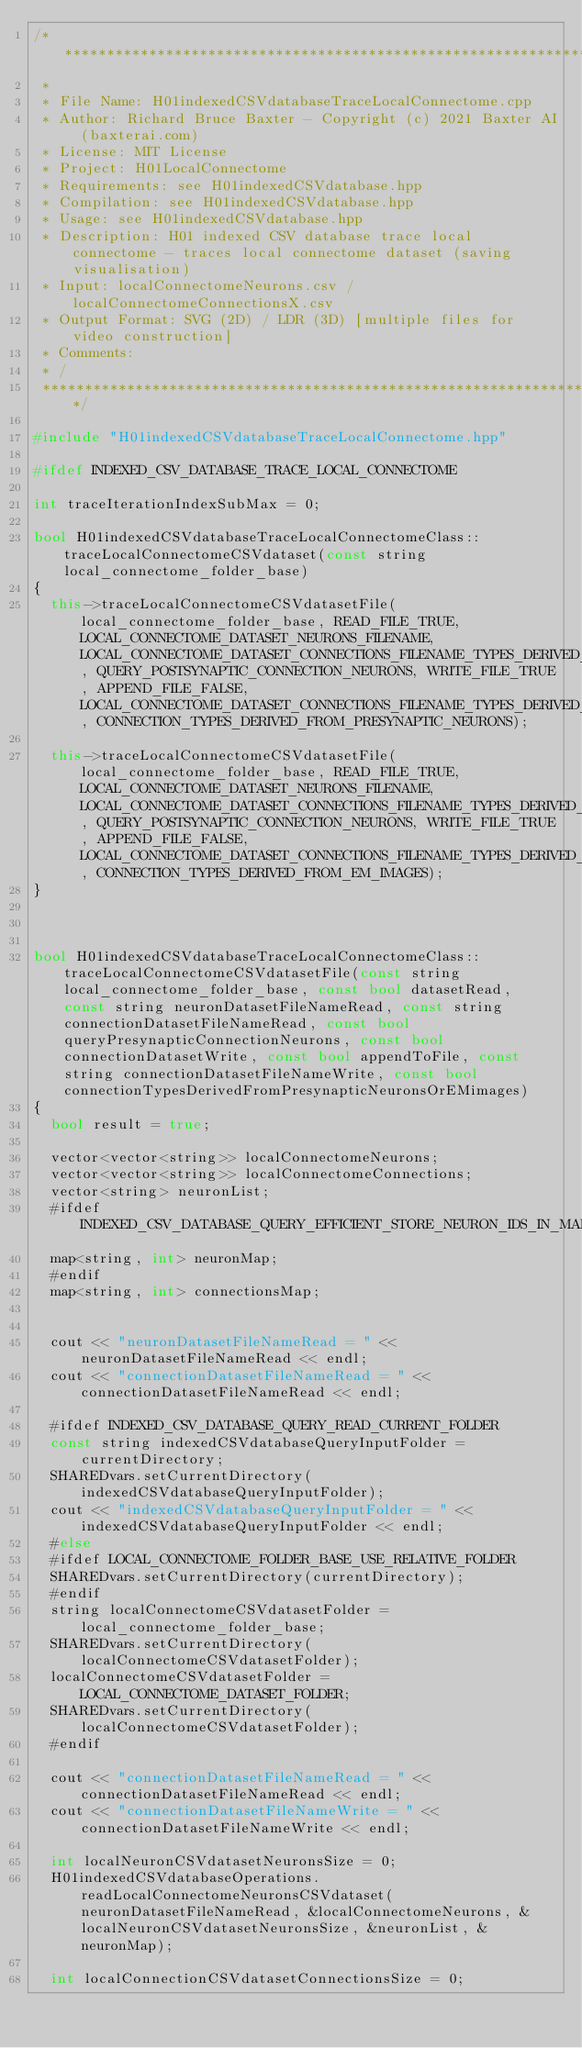<code> <loc_0><loc_0><loc_500><loc_500><_C++_>/*******************************************************************************
 *
 * File Name: H01indexedCSVdatabaseTraceLocalConnectome.cpp
 * Author: Richard Bruce Baxter - Copyright (c) 2021 Baxter AI (baxterai.com)
 * License: MIT License
 * Project: H01LocalConnectome
 * Requirements: see H01indexedCSVdatabase.hpp
 * Compilation: see H01indexedCSVdatabase.hpp
 * Usage: see H01indexedCSVdatabase.hpp
 * Description: H01 indexed CSV database trace local connectome - traces local connectome dataset (saving visualisation)
 * Input: localConnectomeNeurons.csv / localConnectomeConnectionsX.csv
 * Output Format: SVG (2D) / LDR (3D) [multiple files for video construction]
 * Comments:
 * /
 *******************************************************************************/

#include "H01indexedCSVdatabaseTraceLocalConnectome.hpp"

#ifdef INDEXED_CSV_DATABASE_TRACE_LOCAL_CONNECTOME

int traceIterationIndexSubMax = 0;

bool H01indexedCSVdatabaseTraceLocalConnectomeClass::traceLocalConnectomeCSVdataset(const string local_connectome_folder_base)
{
	this->traceLocalConnectomeCSVdatasetFile(local_connectome_folder_base, READ_FILE_TRUE, LOCAL_CONNECTOME_DATASET_NEURONS_FILENAME, LOCAL_CONNECTOME_DATASET_CONNECTIONS_FILENAME_TYPES_DERIVED_FROM_PRESYNAPTIC_NEURONS, QUERY_POSTSYNAPTIC_CONNECTION_NEURONS, WRITE_FILE_TRUE, APPEND_FILE_FALSE, LOCAL_CONNECTOME_DATASET_CONNECTIONS_FILENAME_TYPES_DERIVED_FROM_PRESYNAPTIC_NEURONS, CONNECTION_TYPES_DERIVED_FROM_PRESYNAPTIC_NEURONS);

	this->traceLocalConnectomeCSVdatasetFile(local_connectome_folder_base, READ_FILE_TRUE, LOCAL_CONNECTOME_DATASET_NEURONS_FILENAME, LOCAL_CONNECTOME_DATASET_CONNECTIONS_FILENAME_TYPES_DERIVED_FROM_EM_IMAGES, QUERY_POSTSYNAPTIC_CONNECTION_NEURONS, WRITE_FILE_TRUE, APPEND_FILE_FALSE, LOCAL_CONNECTOME_DATASET_CONNECTIONS_FILENAME_TYPES_DERIVED_FROM_EM_IMAGES, CONNECTION_TYPES_DERIVED_FROM_EM_IMAGES);
}



bool H01indexedCSVdatabaseTraceLocalConnectomeClass::traceLocalConnectomeCSVdatasetFile(const string local_connectome_folder_base, const bool datasetRead, const string neuronDatasetFileNameRead, const string connectionDatasetFileNameRead, const bool queryPresynapticConnectionNeurons, const bool connectionDatasetWrite, const bool appendToFile, const string connectionDatasetFileNameWrite, const bool connectionTypesDerivedFromPresynapticNeuronsOrEMimages)
{
	bool result = true;
		
	vector<vector<string>> localConnectomeNeurons;
	vector<vector<string>> localConnectomeConnections;
	vector<string> neuronList;
	#ifdef INDEXED_CSV_DATABASE_QUERY_EFFICIENT_STORE_NEURON_IDS_IN_MAP
	map<string, int> neuronMap;
	#endif
	map<string, int> connectionsMap;
			

	cout << "neuronDatasetFileNameRead = " << neuronDatasetFileNameRead << endl;
	cout << "connectionDatasetFileNameRead = " << connectionDatasetFileNameRead << endl;

	#ifdef INDEXED_CSV_DATABASE_QUERY_READ_CURRENT_FOLDER
	const string indexedCSVdatabaseQueryInputFolder = currentDirectory;	
	SHAREDvars.setCurrentDirectory(indexedCSVdatabaseQueryInputFolder);
	cout << "indexedCSVdatabaseQueryInputFolder = " << indexedCSVdatabaseQueryInputFolder << endl;
	#else
	#ifdef LOCAL_CONNECTOME_FOLDER_BASE_USE_RELATIVE_FOLDER
	SHAREDvars.setCurrentDirectory(currentDirectory);
	#endif
	string localConnectomeCSVdatasetFolder = local_connectome_folder_base;
	SHAREDvars.setCurrentDirectory(localConnectomeCSVdatasetFolder);
	localConnectomeCSVdatasetFolder = LOCAL_CONNECTOME_DATASET_FOLDER;
	SHAREDvars.setCurrentDirectory(localConnectomeCSVdatasetFolder);
	#endif

	cout << "connectionDatasetFileNameRead = " << connectionDatasetFileNameRead << endl;
	cout << "connectionDatasetFileNameWrite = " << connectionDatasetFileNameWrite << endl;

	int localNeuronCSVdatasetNeuronsSize = 0;
	H01indexedCSVdatabaseOperations.readLocalConnectomeNeuronsCSVdataset(neuronDatasetFileNameRead, &localConnectomeNeurons, &localNeuronCSVdatasetNeuronsSize, &neuronList, &neuronMap);

	int localConnectionCSVdatasetConnectionsSize = 0;</code> 